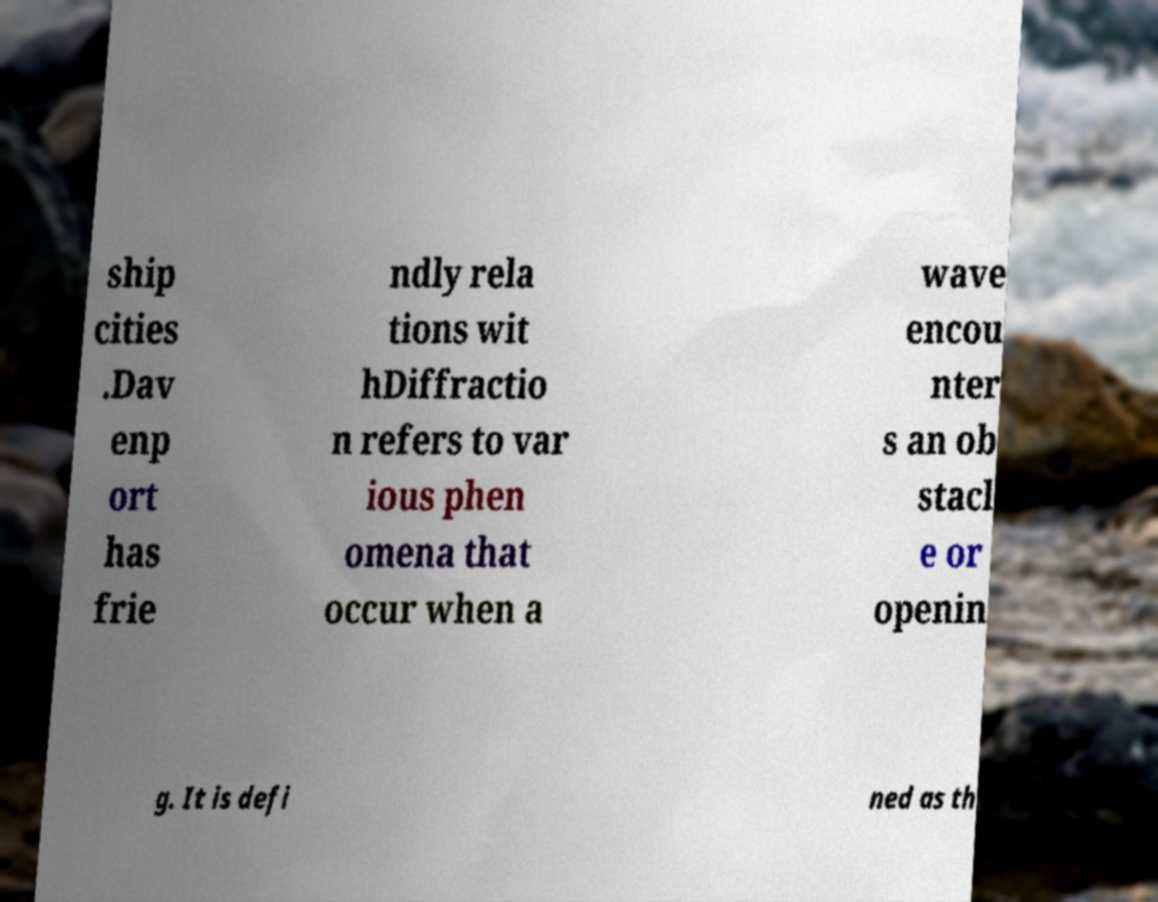Could you extract and type out the text from this image? ship cities .Dav enp ort has frie ndly rela tions wit hDiffractio n refers to var ious phen omena that occur when a wave encou nter s an ob stacl e or openin g. It is defi ned as th 